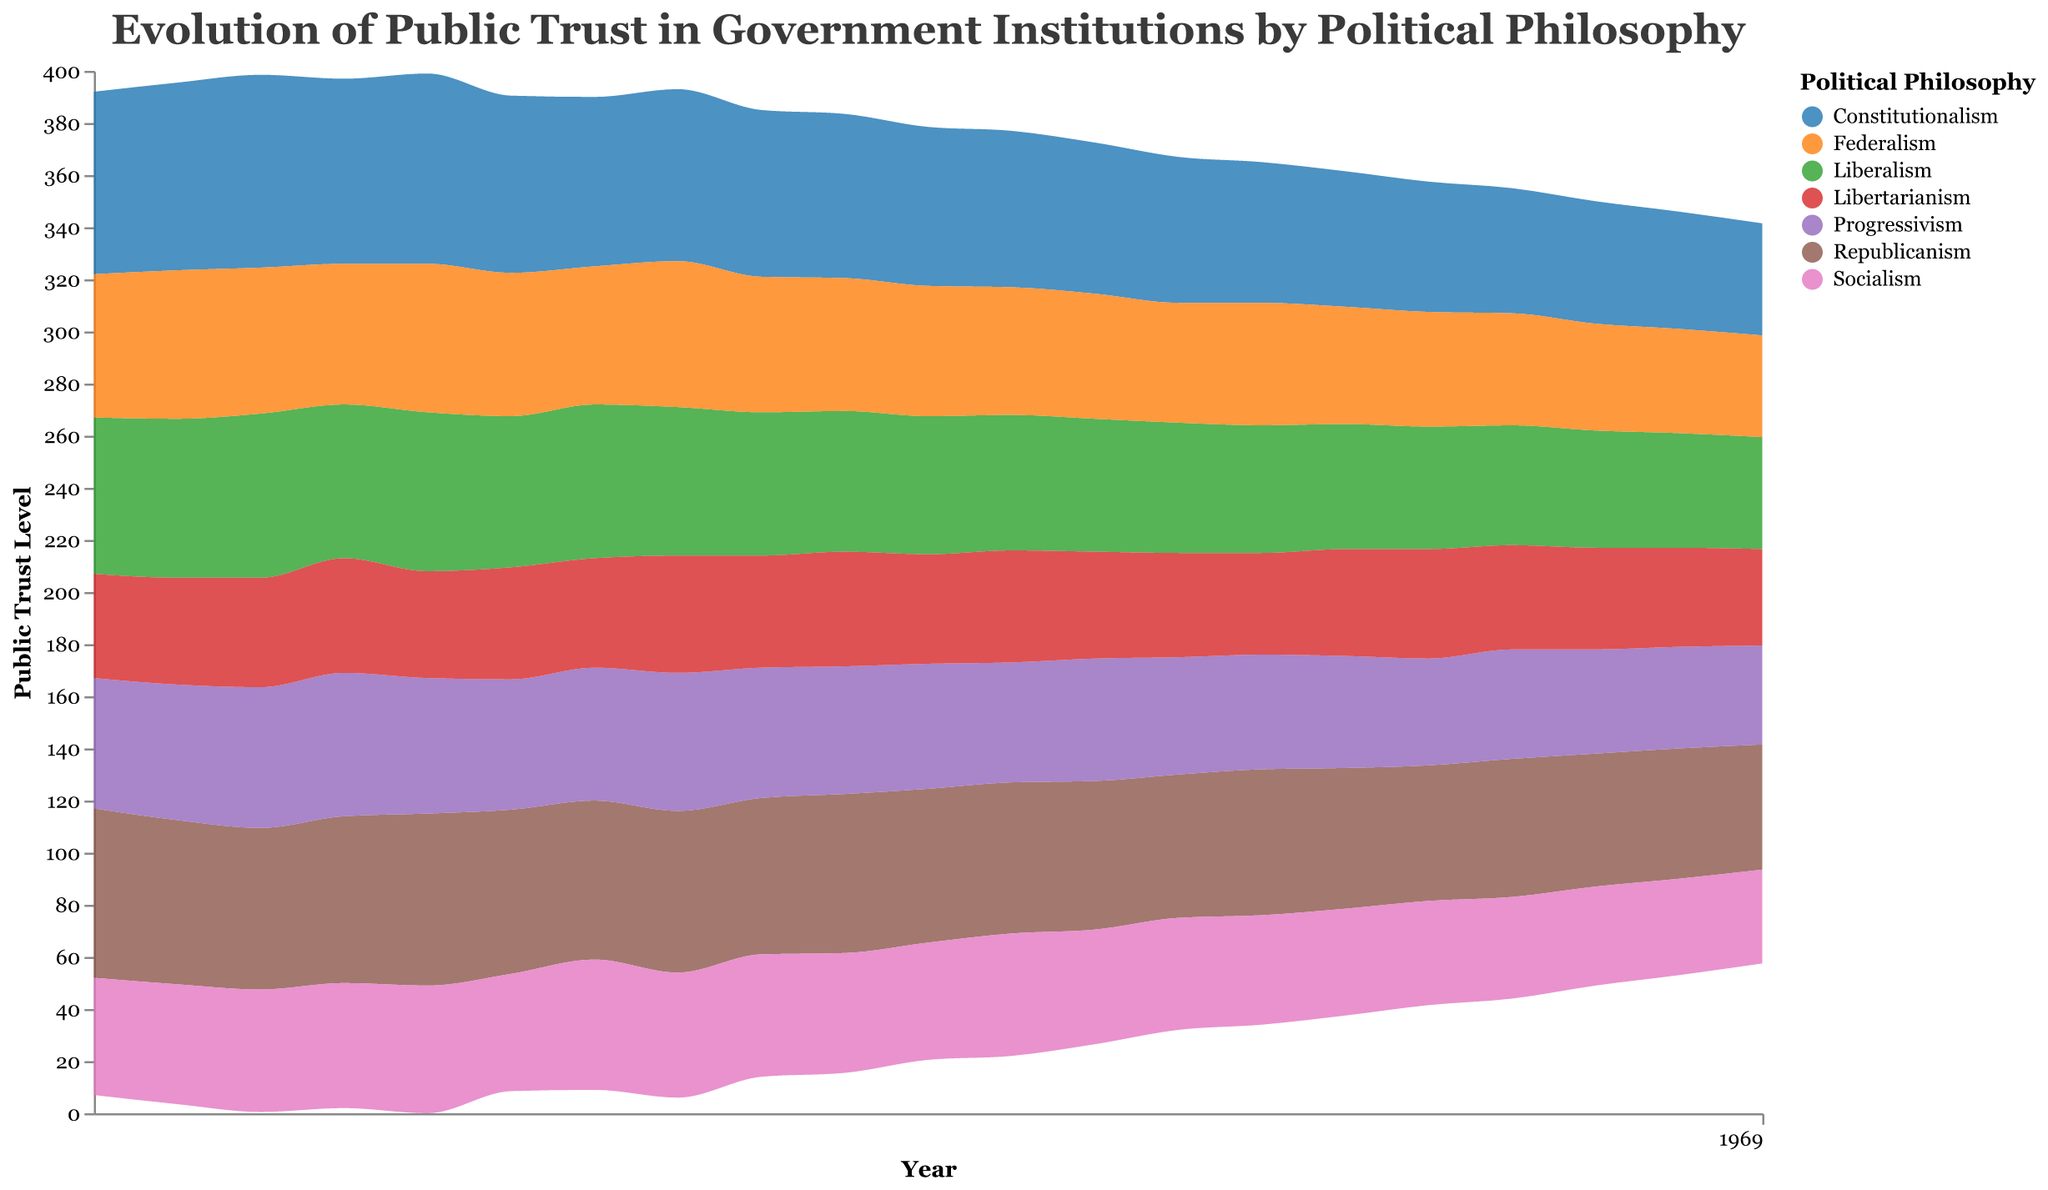What is the title of the figure? The title of the figure is displayed prominently at the top in a large font. According to the provided data and code, the title of the figure is "Evolution of Public Trust in Government Institutions by Political Philosophy."
Answer: Evolution of Public Trust in Government Institutions by Political Philosophy How many political philosophies are represented in the graph? By examining the legend and the data descriptions within the code, there are seven political philosophies represented in the graph.
Answer: Seven In what year did Constitutionalism have the highest trust level? By analyzing the data points or the stream graph, Constitutionalism had the highest trust level in 2002.
Answer: 2002 Which political philosophy had the lowest trust level in 2020? According to the values from the data and visualized in the figure, Libertarianism had the lowest trust level in 2020.
Answer: Libertarianism Compare the trust level in 2000 between Constitutionalism and Socialism. Which one was higher, and by how much? In 2000, Constitutionalism had a trust level of 70, and Socialism had a trust level of 45. To compare, 70 - 45 = 25, making Constitutionalism higher by 25 units.
Answer: Constitutionalism by 25 units How did the trust in Progressivism change from 2005 to 2010? From the data, the trust levels in Progressivism in 2005 and 2010 were 50 and 48, respectively. The change is calculated as 48 - 50 = -2, indicating a decrease of 2 units.
Answer: Decreased by 2 units Between which years did Liberalism experience the largest drop in trust level? From the data, Liberalism experienced a drop from 63 in 2002 to 59 in 2003, a decrease of 4 units. A visual inspection of the graph confirms this.
Answer: 2002 to 2003 In which year did Socialism achieve its peak trust value? By examining the peak values on the graph and the corresponding years, Socialism achieved its peak trust value in 2006.
Answer: 2006 What is the overall trend in public trust in Federalism from 2000 to 2020? Observing the stream graph, Federalism generally shows a declining trend over the years from 2000 (55) to 2020 (39).
Answer: Declining trend Which political philosophy showed the most stability in trust level between 2000 and 2020? By examining the figure, Libertarianism displayed relatively minor fluctuations and had the most stable trend, with the trust level varying between 37 and 45.
Answer: Libertarianism 